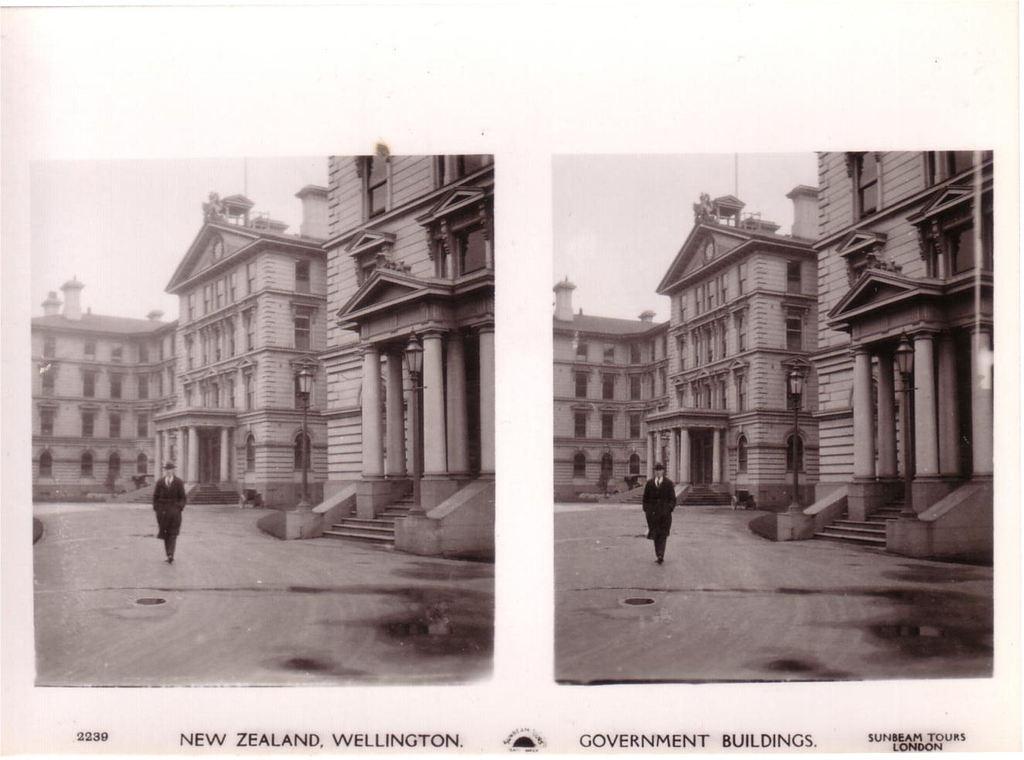Can you describe this image briefly? It is a collage image, in the image we can see a person and buildings. 